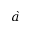Convert formula to latex. <formula><loc_0><loc_0><loc_500><loc_500>\grave { a }</formula> 